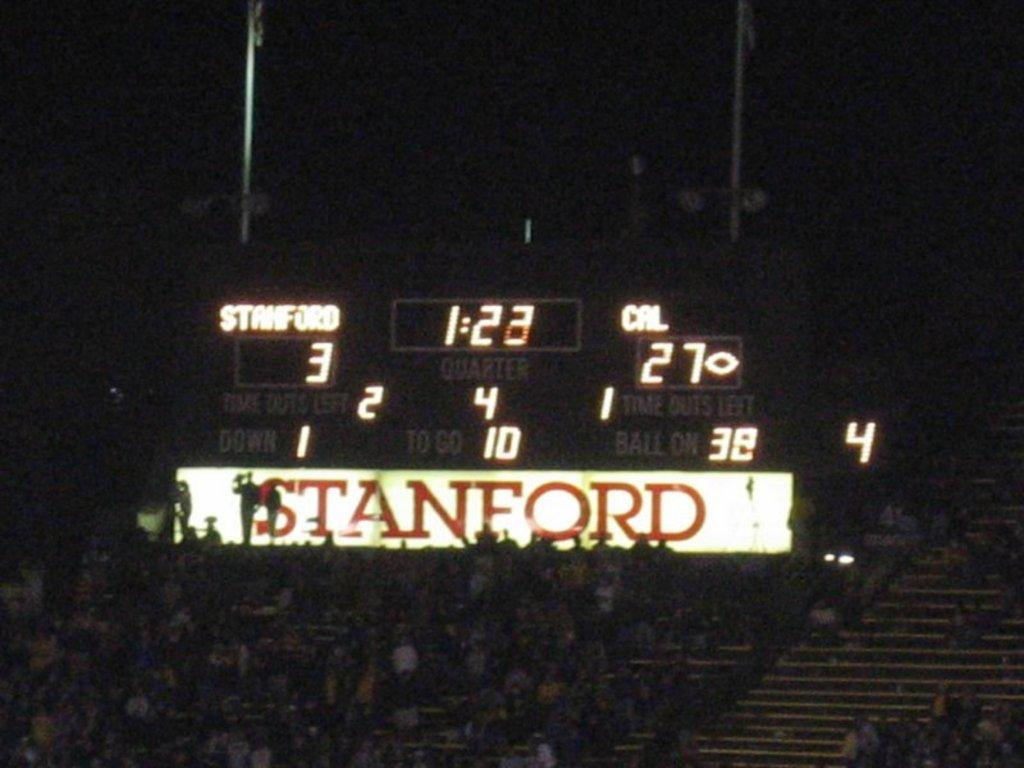<image>
Summarize the visual content of the image. A large digital scoreboard with the word Stanford on it. 